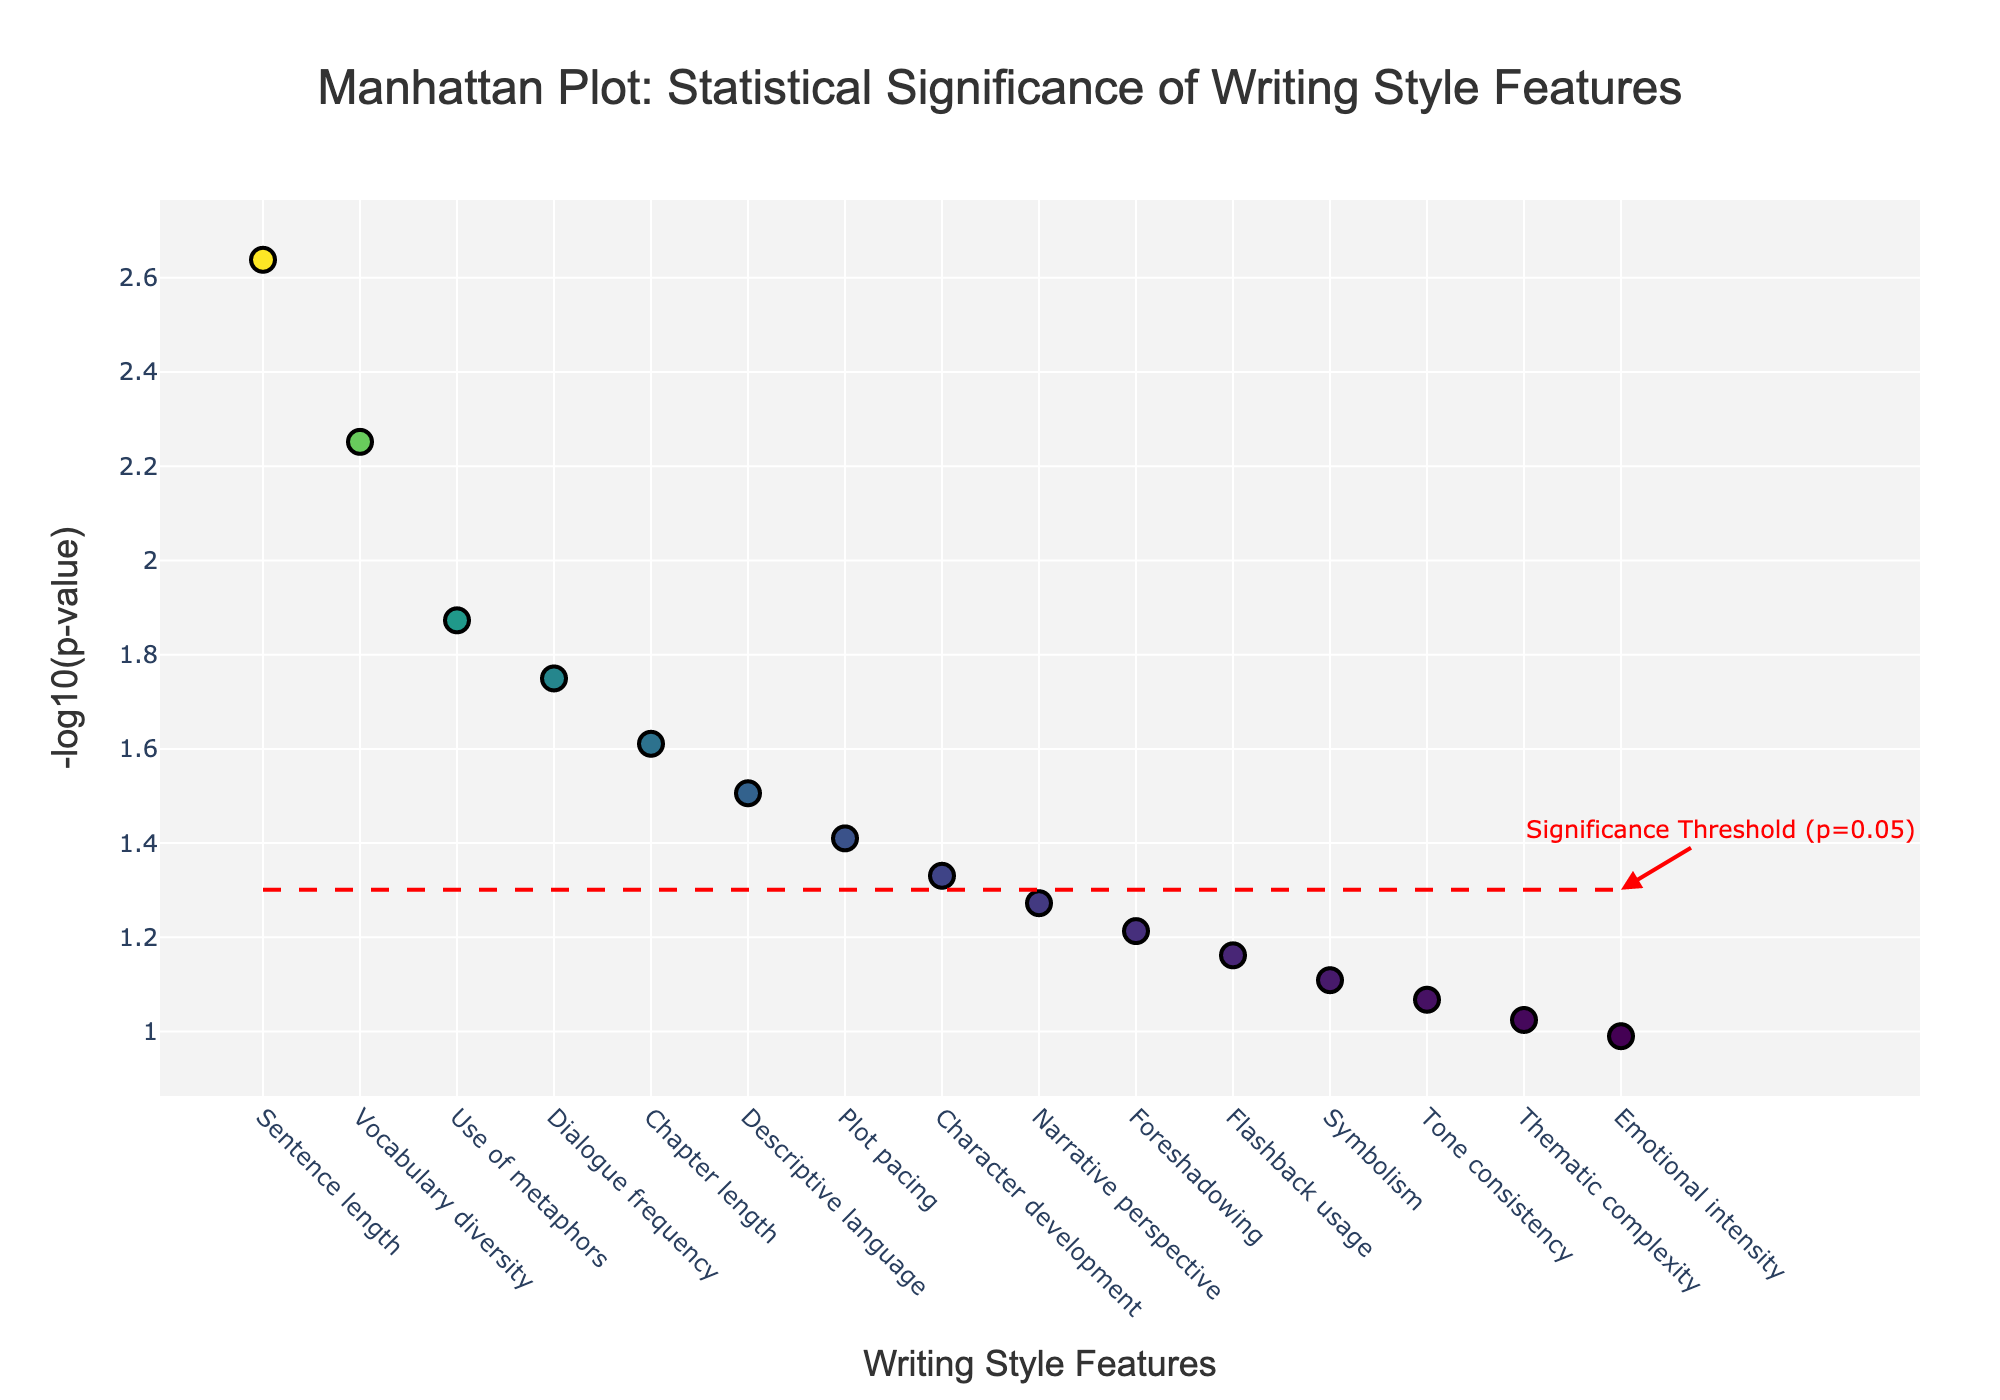What is the title of the plot? The title of the plot is prominently displayed at the top of the figure. Reading it directly from the visual information provides the title.
Answer: Manhattan Plot: Statistical Significance of Writing Style Features How many writing style features have p-values less than 0.05? Look at the number of markers above the red dashed significance threshold line at y = -log10(0.05) and count the points.
Answer: 8 Which writing style feature has the smallest p-value? Identify the point with the highest y-value on the plot since -log10(p-value) is inversely related to p-value. Check the corresponding x-axis label for this point.
Answer: Sentence length What is the y-value for the "Narrative perspective" feature? Locate the "Narrative perspective" feature on the x-axis, then find its corresponding y-value (-log10(p)) on the plot.
Answer: -1.2725 Which two features have the closest y-values? Look at the markers and identify two features whose y-values are close to each other. Compare their height along the y-axis visually.
Answer: Narrative perspective and Foreshadowing How many features have p-values greater than 0.05? Count the number of markers below the red dashed significance threshold line at y = -log10(0.05). Essentially, subtract the number of significant features from the total number of features.
Answer: 7 Which feature has a y-value closest to 1.5? Scan the plot to find the marker closest to 1.5 on the y-axis and check the corresponding feature on the x-axis.
Answer: Use of metaphors Are there any features with a p-value exactly less than 0.01? Check the plot for markers with y-values equal to or above -log10(0.01). Based on the data points' positions, determine if there are any that meet the criteria.
Answer: No What is the difference in y-values between "Character development" and "Foreshadowing"? Find the y-values for "Character development" and "Foreshadowing" on the plot and calculate the difference.
Answer: 0.10595 